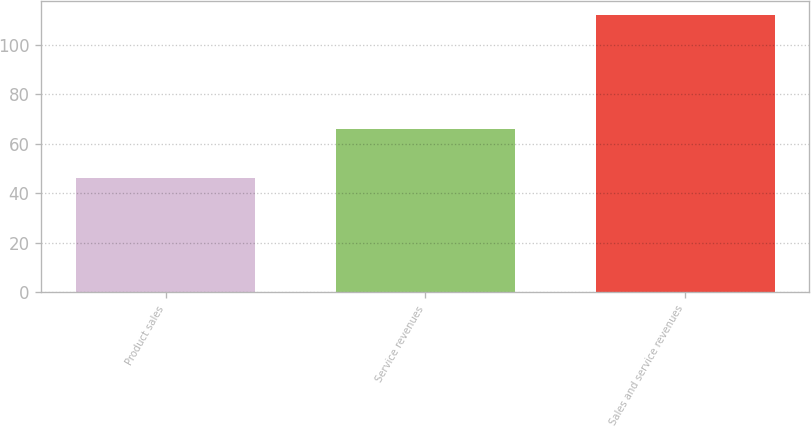Convert chart. <chart><loc_0><loc_0><loc_500><loc_500><bar_chart><fcel>Product sales<fcel>Service revenues<fcel>Sales and service revenues<nl><fcel>46<fcel>66<fcel>112<nl></chart> 